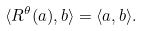<formula> <loc_0><loc_0><loc_500><loc_500>\langle R ^ { \theta } ( a ) , b \rangle = \langle a , b \rangle .</formula> 